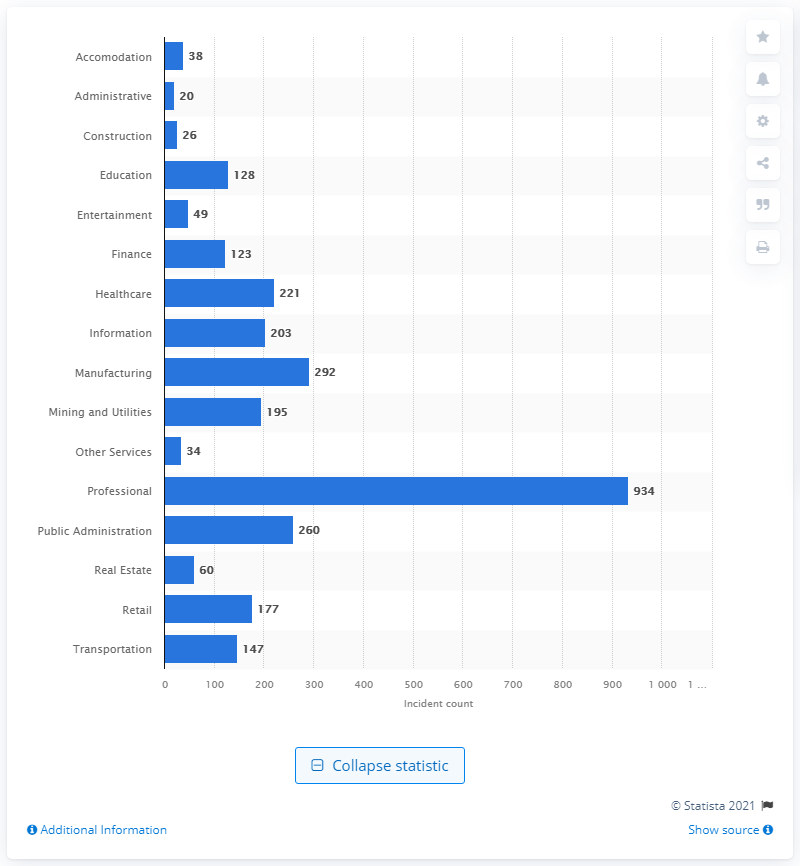Identify some key points in this picture. In 2020, there were 934 reported incidents of malware in the professional sector. 